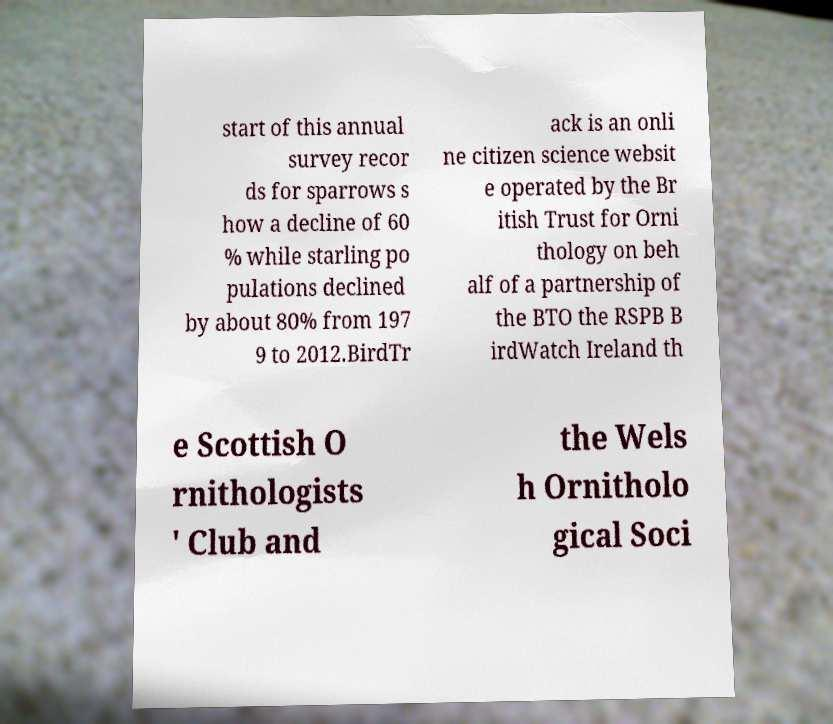Can you accurately transcribe the text from the provided image for me? start of this annual survey recor ds for sparrows s how a decline of 60 % while starling po pulations declined by about 80% from 197 9 to 2012.BirdTr ack is an onli ne citizen science websit e operated by the Br itish Trust for Orni thology on beh alf of a partnership of the BTO the RSPB B irdWatch Ireland th e Scottish O rnithologists ' Club and the Wels h Ornitholo gical Soci 